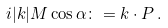<formula> <loc_0><loc_0><loc_500><loc_500>i | k | M \cos \alpha \colon = k \cdot P \, .</formula> 